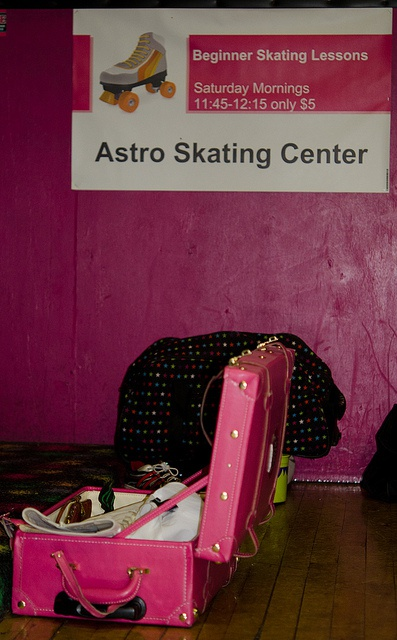Describe the objects in this image and their specific colors. I can see a suitcase in black, brown, and maroon tones in this image. 